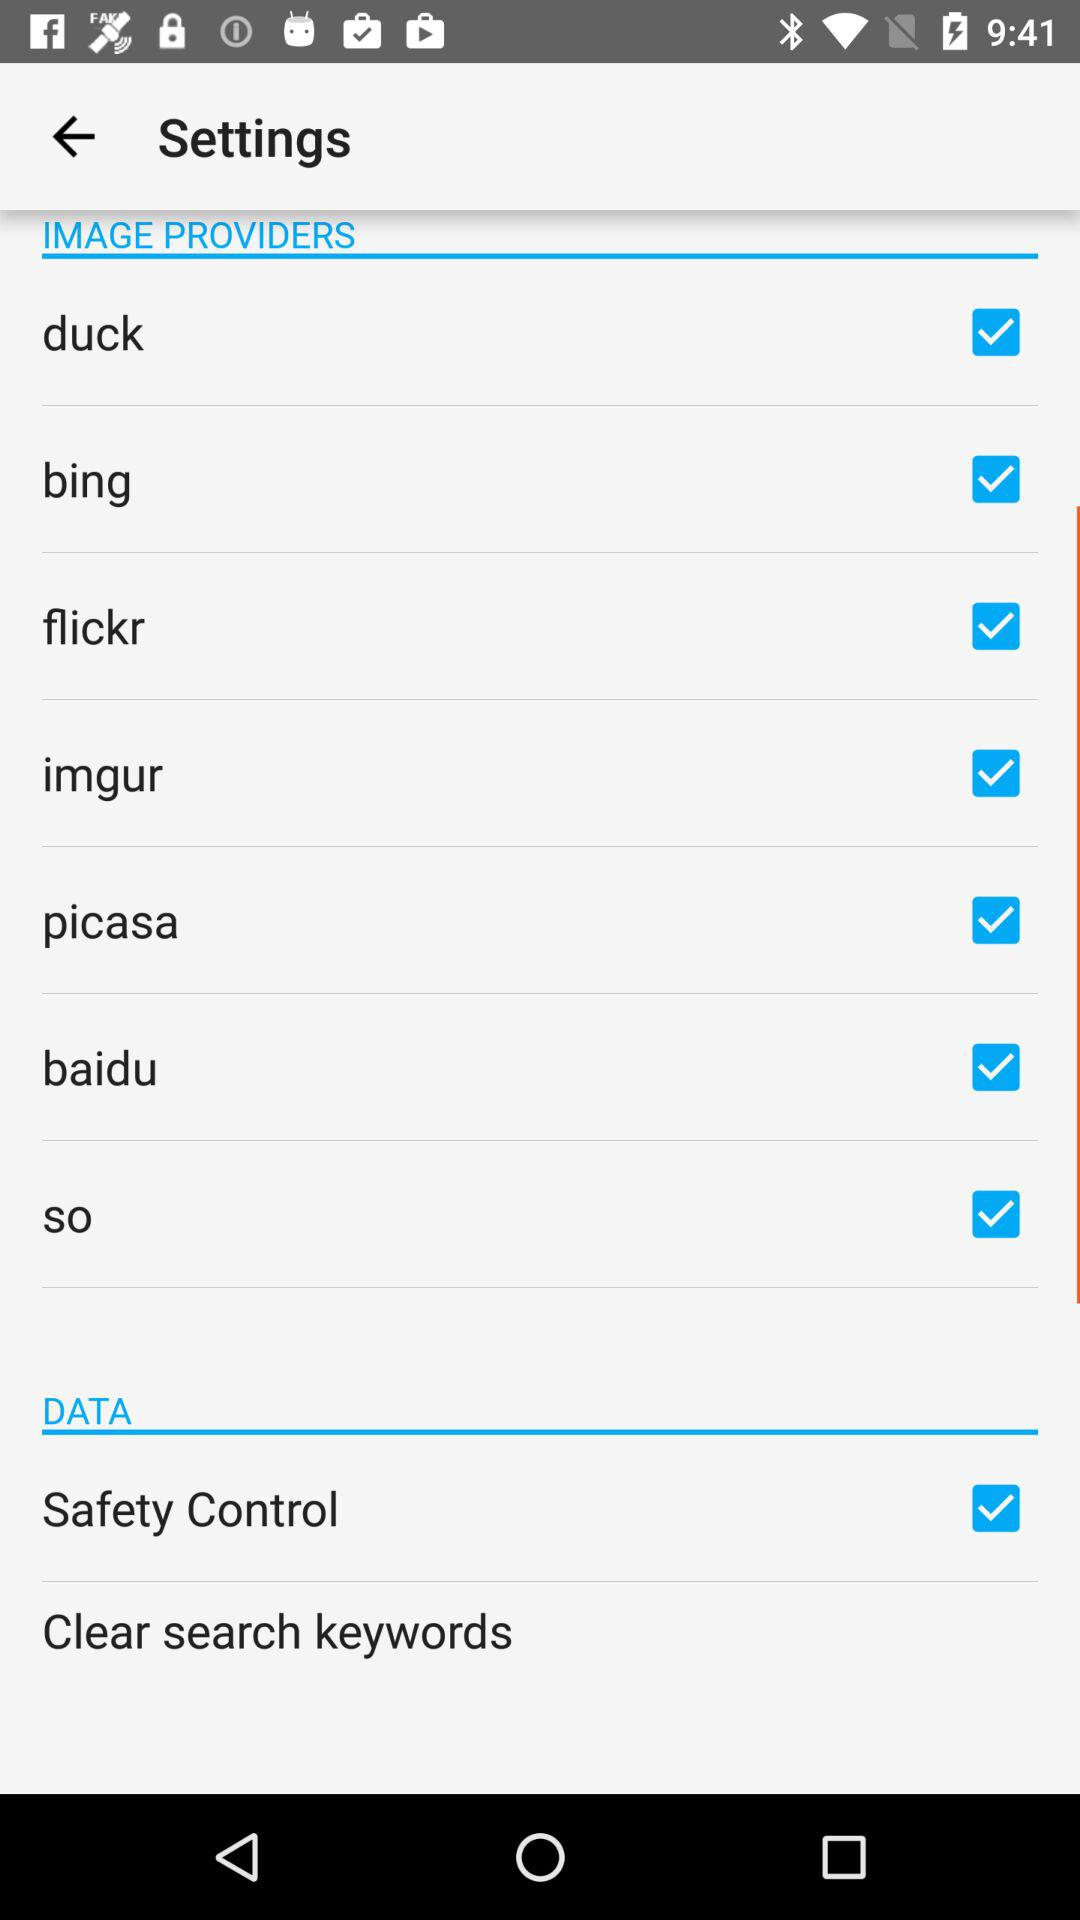What is the status of "flickr"? The status of "flickr" is "on". 